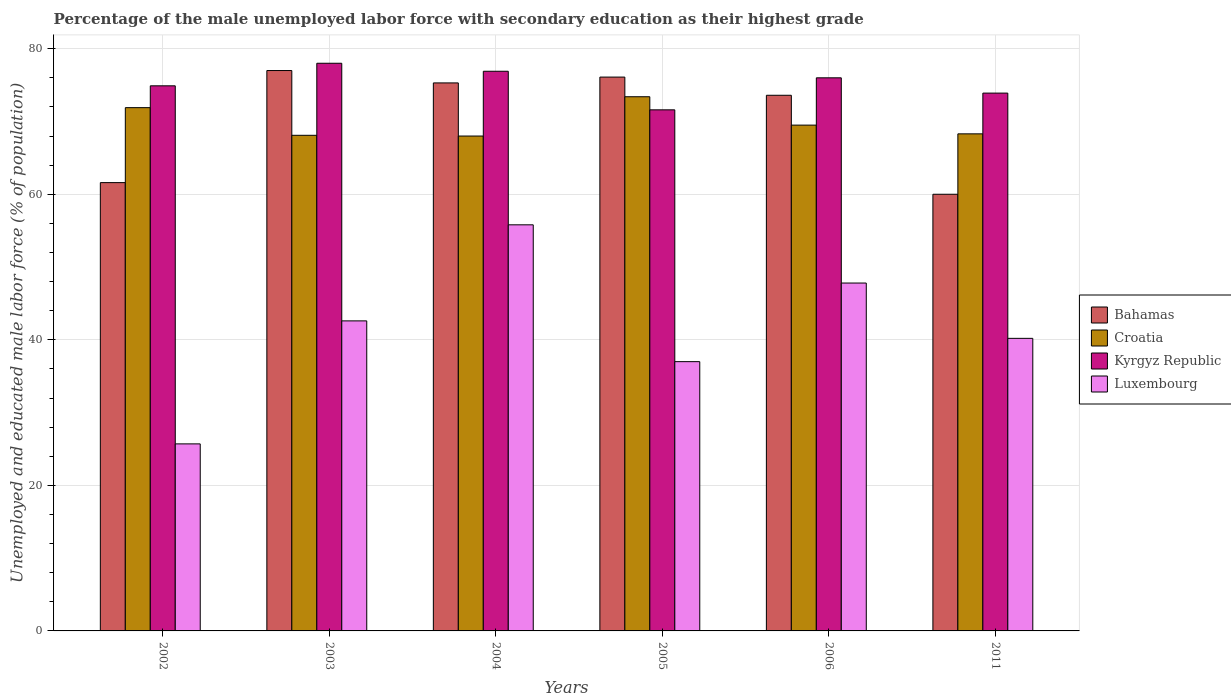How many different coloured bars are there?
Your answer should be compact. 4. How many groups of bars are there?
Offer a very short reply. 6. Are the number of bars per tick equal to the number of legend labels?
Provide a short and direct response. Yes. Are the number of bars on each tick of the X-axis equal?
Ensure brevity in your answer.  Yes. What is the percentage of the unemployed male labor force with secondary education in Luxembourg in 2011?
Your response must be concise. 40.2. Across all years, what is the maximum percentage of the unemployed male labor force with secondary education in Croatia?
Offer a terse response. 73.4. Across all years, what is the minimum percentage of the unemployed male labor force with secondary education in Kyrgyz Republic?
Offer a terse response. 71.6. In which year was the percentage of the unemployed male labor force with secondary education in Croatia maximum?
Your answer should be very brief. 2005. What is the total percentage of the unemployed male labor force with secondary education in Bahamas in the graph?
Offer a terse response. 423.6. What is the difference between the percentage of the unemployed male labor force with secondary education in Luxembourg in 2005 and that in 2006?
Provide a short and direct response. -10.8. What is the difference between the percentage of the unemployed male labor force with secondary education in Luxembourg in 2003 and the percentage of the unemployed male labor force with secondary education in Bahamas in 2006?
Make the answer very short. -31. What is the average percentage of the unemployed male labor force with secondary education in Croatia per year?
Ensure brevity in your answer.  69.87. In the year 2011, what is the difference between the percentage of the unemployed male labor force with secondary education in Luxembourg and percentage of the unemployed male labor force with secondary education in Kyrgyz Republic?
Offer a terse response. -33.7. In how many years, is the percentage of the unemployed male labor force with secondary education in Kyrgyz Republic greater than 44 %?
Offer a very short reply. 6. What is the ratio of the percentage of the unemployed male labor force with secondary education in Bahamas in 2002 to that in 2011?
Offer a very short reply. 1.03. Is the difference between the percentage of the unemployed male labor force with secondary education in Luxembourg in 2002 and 2004 greater than the difference between the percentage of the unemployed male labor force with secondary education in Kyrgyz Republic in 2002 and 2004?
Provide a succinct answer. No. What is the difference between the highest and the second highest percentage of the unemployed male labor force with secondary education in Luxembourg?
Provide a succinct answer. 8. What is the difference between the highest and the lowest percentage of the unemployed male labor force with secondary education in Croatia?
Your answer should be very brief. 5.4. Is the sum of the percentage of the unemployed male labor force with secondary education in Bahamas in 2002 and 2004 greater than the maximum percentage of the unemployed male labor force with secondary education in Luxembourg across all years?
Give a very brief answer. Yes. Is it the case that in every year, the sum of the percentage of the unemployed male labor force with secondary education in Kyrgyz Republic and percentage of the unemployed male labor force with secondary education in Luxembourg is greater than the sum of percentage of the unemployed male labor force with secondary education in Bahamas and percentage of the unemployed male labor force with secondary education in Croatia?
Provide a succinct answer. No. What does the 3rd bar from the left in 2006 represents?
Provide a succinct answer. Kyrgyz Republic. What does the 1st bar from the right in 2006 represents?
Offer a terse response. Luxembourg. How many bars are there?
Provide a succinct answer. 24. How many years are there in the graph?
Provide a succinct answer. 6. What is the difference between two consecutive major ticks on the Y-axis?
Offer a terse response. 20. Where does the legend appear in the graph?
Offer a terse response. Center right. How many legend labels are there?
Offer a terse response. 4. What is the title of the graph?
Your answer should be compact. Percentage of the male unemployed labor force with secondary education as their highest grade. Does "Iraq" appear as one of the legend labels in the graph?
Make the answer very short. No. What is the label or title of the X-axis?
Give a very brief answer. Years. What is the label or title of the Y-axis?
Your answer should be very brief. Unemployed and educated male labor force (% of population). What is the Unemployed and educated male labor force (% of population) in Bahamas in 2002?
Provide a succinct answer. 61.6. What is the Unemployed and educated male labor force (% of population) of Croatia in 2002?
Keep it short and to the point. 71.9. What is the Unemployed and educated male labor force (% of population) of Kyrgyz Republic in 2002?
Your response must be concise. 74.9. What is the Unemployed and educated male labor force (% of population) of Luxembourg in 2002?
Your answer should be compact. 25.7. What is the Unemployed and educated male labor force (% of population) of Bahamas in 2003?
Make the answer very short. 77. What is the Unemployed and educated male labor force (% of population) in Croatia in 2003?
Offer a very short reply. 68.1. What is the Unemployed and educated male labor force (% of population) of Kyrgyz Republic in 2003?
Offer a very short reply. 78. What is the Unemployed and educated male labor force (% of population) of Luxembourg in 2003?
Make the answer very short. 42.6. What is the Unemployed and educated male labor force (% of population) of Bahamas in 2004?
Your response must be concise. 75.3. What is the Unemployed and educated male labor force (% of population) of Croatia in 2004?
Keep it short and to the point. 68. What is the Unemployed and educated male labor force (% of population) of Kyrgyz Republic in 2004?
Offer a terse response. 76.9. What is the Unemployed and educated male labor force (% of population) in Luxembourg in 2004?
Ensure brevity in your answer.  55.8. What is the Unemployed and educated male labor force (% of population) in Bahamas in 2005?
Keep it short and to the point. 76.1. What is the Unemployed and educated male labor force (% of population) in Croatia in 2005?
Your answer should be very brief. 73.4. What is the Unemployed and educated male labor force (% of population) of Kyrgyz Republic in 2005?
Make the answer very short. 71.6. What is the Unemployed and educated male labor force (% of population) of Luxembourg in 2005?
Offer a terse response. 37. What is the Unemployed and educated male labor force (% of population) of Bahamas in 2006?
Offer a terse response. 73.6. What is the Unemployed and educated male labor force (% of population) in Croatia in 2006?
Give a very brief answer. 69.5. What is the Unemployed and educated male labor force (% of population) in Kyrgyz Republic in 2006?
Offer a terse response. 76. What is the Unemployed and educated male labor force (% of population) of Luxembourg in 2006?
Offer a very short reply. 47.8. What is the Unemployed and educated male labor force (% of population) in Bahamas in 2011?
Provide a short and direct response. 60. What is the Unemployed and educated male labor force (% of population) in Croatia in 2011?
Keep it short and to the point. 68.3. What is the Unemployed and educated male labor force (% of population) of Kyrgyz Republic in 2011?
Ensure brevity in your answer.  73.9. What is the Unemployed and educated male labor force (% of population) in Luxembourg in 2011?
Provide a short and direct response. 40.2. Across all years, what is the maximum Unemployed and educated male labor force (% of population) of Croatia?
Keep it short and to the point. 73.4. Across all years, what is the maximum Unemployed and educated male labor force (% of population) of Luxembourg?
Give a very brief answer. 55.8. Across all years, what is the minimum Unemployed and educated male labor force (% of population) in Bahamas?
Give a very brief answer. 60. Across all years, what is the minimum Unemployed and educated male labor force (% of population) in Croatia?
Make the answer very short. 68. Across all years, what is the minimum Unemployed and educated male labor force (% of population) in Kyrgyz Republic?
Provide a short and direct response. 71.6. Across all years, what is the minimum Unemployed and educated male labor force (% of population) of Luxembourg?
Your answer should be compact. 25.7. What is the total Unemployed and educated male labor force (% of population) of Bahamas in the graph?
Your answer should be compact. 423.6. What is the total Unemployed and educated male labor force (% of population) of Croatia in the graph?
Offer a very short reply. 419.2. What is the total Unemployed and educated male labor force (% of population) in Kyrgyz Republic in the graph?
Your response must be concise. 451.3. What is the total Unemployed and educated male labor force (% of population) of Luxembourg in the graph?
Your response must be concise. 249.1. What is the difference between the Unemployed and educated male labor force (% of population) of Bahamas in 2002 and that in 2003?
Keep it short and to the point. -15.4. What is the difference between the Unemployed and educated male labor force (% of population) of Luxembourg in 2002 and that in 2003?
Your answer should be very brief. -16.9. What is the difference between the Unemployed and educated male labor force (% of population) of Bahamas in 2002 and that in 2004?
Offer a very short reply. -13.7. What is the difference between the Unemployed and educated male labor force (% of population) of Kyrgyz Republic in 2002 and that in 2004?
Provide a short and direct response. -2. What is the difference between the Unemployed and educated male labor force (% of population) in Luxembourg in 2002 and that in 2004?
Give a very brief answer. -30.1. What is the difference between the Unemployed and educated male labor force (% of population) in Kyrgyz Republic in 2002 and that in 2005?
Provide a succinct answer. 3.3. What is the difference between the Unemployed and educated male labor force (% of population) of Luxembourg in 2002 and that in 2005?
Provide a succinct answer. -11.3. What is the difference between the Unemployed and educated male labor force (% of population) of Bahamas in 2002 and that in 2006?
Ensure brevity in your answer.  -12. What is the difference between the Unemployed and educated male labor force (% of population) of Kyrgyz Republic in 2002 and that in 2006?
Provide a short and direct response. -1.1. What is the difference between the Unemployed and educated male labor force (% of population) in Luxembourg in 2002 and that in 2006?
Give a very brief answer. -22.1. What is the difference between the Unemployed and educated male labor force (% of population) of Bahamas in 2003 and that in 2004?
Give a very brief answer. 1.7. What is the difference between the Unemployed and educated male labor force (% of population) of Croatia in 2003 and that in 2004?
Provide a short and direct response. 0.1. What is the difference between the Unemployed and educated male labor force (% of population) of Bahamas in 2003 and that in 2005?
Offer a very short reply. 0.9. What is the difference between the Unemployed and educated male labor force (% of population) of Croatia in 2003 and that in 2005?
Offer a very short reply. -5.3. What is the difference between the Unemployed and educated male labor force (% of population) of Croatia in 2003 and that in 2011?
Keep it short and to the point. -0.2. What is the difference between the Unemployed and educated male labor force (% of population) in Kyrgyz Republic in 2003 and that in 2011?
Give a very brief answer. 4.1. What is the difference between the Unemployed and educated male labor force (% of population) in Luxembourg in 2003 and that in 2011?
Provide a succinct answer. 2.4. What is the difference between the Unemployed and educated male labor force (% of population) of Bahamas in 2004 and that in 2005?
Make the answer very short. -0.8. What is the difference between the Unemployed and educated male labor force (% of population) in Kyrgyz Republic in 2004 and that in 2005?
Make the answer very short. 5.3. What is the difference between the Unemployed and educated male labor force (% of population) in Croatia in 2004 and that in 2006?
Make the answer very short. -1.5. What is the difference between the Unemployed and educated male labor force (% of population) of Kyrgyz Republic in 2004 and that in 2006?
Offer a very short reply. 0.9. What is the difference between the Unemployed and educated male labor force (% of population) of Luxembourg in 2004 and that in 2006?
Offer a very short reply. 8. What is the difference between the Unemployed and educated male labor force (% of population) of Bahamas in 2004 and that in 2011?
Make the answer very short. 15.3. What is the difference between the Unemployed and educated male labor force (% of population) of Croatia in 2004 and that in 2011?
Your response must be concise. -0.3. What is the difference between the Unemployed and educated male labor force (% of population) of Bahamas in 2005 and that in 2006?
Ensure brevity in your answer.  2.5. What is the difference between the Unemployed and educated male labor force (% of population) of Luxembourg in 2005 and that in 2006?
Give a very brief answer. -10.8. What is the difference between the Unemployed and educated male labor force (% of population) in Croatia in 2005 and that in 2011?
Your response must be concise. 5.1. What is the difference between the Unemployed and educated male labor force (% of population) of Croatia in 2006 and that in 2011?
Give a very brief answer. 1.2. What is the difference between the Unemployed and educated male labor force (% of population) in Luxembourg in 2006 and that in 2011?
Your response must be concise. 7.6. What is the difference between the Unemployed and educated male labor force (% of population) of Bahamas in 2002 and the Unemployed and educated male labor force (% of population) of Kyrgyz Republic in 2003?
Your answer should be very brief. -16.4. What is the difference between the Unemployed and educated male labor force (% of population) in Bahamas in 2002 and the Unemployed and educated male labor force (% of population) in Luxembourg in 2003?
Offer a terse response. 19. What is the difference between the Unemployed and educated male labor force (% of population) in Croatia in 2002 and the Unemployed and educated male labor force (% of population) in Kyrgyz Republic in 2003?
Provide a short and direct response. -6.1. What is the difference between the Unemployed and educated male labor force (% of population) in Croatia in 2002 and the Unemployed and educated male labor force (% of population) in Luxembourg in 2003?
Make the answer very short. 29.3. What is the difference between the Unemployed and educated male labor force (% of population) of Kyrgyz Republic in 2002 and the Unemployed and educated male labor force (% of population) of Luxembourg in 2003?
Provide a succinct answer. 32.3. What is the difference between the Unemployed and educated male labor force (% of population) of Bahamas in 2002 and the Unemployed and educated male labor force (% of population) of Croatia in 2004?
Provide a short and direct response. -6.4. What is the difference between the Unemployed and educated male labor force (% of population) of Bahamas in 2002 and the Unemployed and educated male labor force (% of population) of Kyrgyz Republic in 2004?
Keep it short and to the point. -15.3. What is the difference between the Unemployed and educated male labor force (% of population) in Bahamas in 2002 and the Unemployed and educated male labor force (% of population) in Luxembourg in 2004?
Offer a terse response. 5.8. What is the difference between the Unemployed and educated male labor force (% of population) of Croatia in 2002 and the Unemployed and educated male labor force (% of population) of Kyrgyz Republic in 2004?
Your response must be concise. -5. What is the difference between the Unemployed and educated male labor force (% of population) of Kyrgyz Republic in 2002 and the Unemployed and educated male labor force (% of population) of Luxembourg in 2004?
Offer a terse response. 19.1. What is the difference between the Unemployed and educated male labor force (% of population) in Bahamas in 2002 and the Unemployed and educated male labor force (% of population) in Luxembourg in 2005?
Provide a succinct answer. 24.6. What is the difference between the Unemployed and educated male labor force (% of population) in Croatia in 2002 and the Unemployed and educated male labor force (% of population) in Kyrgyz Republic in 2005?
Your answer should be compact. 0.3. What is the difference between the Unemployed and educated male labor force (% of population) in Croatia in 2002 and the Unemployed and educated male labor force (% of population) in Luxembourg in 2005?
Your answer should be compact. 34.9. What is the difference between the Unemployed and educated male labor force (% of population) in Kyrgyz Republic in 2002 and the Unemployed and educated male labor force (% of population) in Luxembourg in 2005?
Your response must be concise. 37.9. What is the difference between the Unemployed and educated male labor force (% of population) in Bahamas in 2002 and the Unemployed and educated male labor force (% of population) in Kyrgyz Republic in 2006?
Make the answer very short. -14.4. What is the difference between the Unemployed and educated male labor force (% of population) in Bahamas in 2002 and the Unemployed and educated male labor force (% of population) in Luxembourg in 2006?
Provide a succinct answer. 13.8. What is the difference between the Unemployed and educated male labor force (% of population) in Croatia in 2002 and the Unemployed and educated male labor force (% of population) in Luxembourg in 2006?
Your answer should be very brief. 24.1. What is the difference between the Unemployed and educated male labor force (% of population) in Kyrgyz Republic in 2002 and the Unemployed and educated male labor force (% of population) in Luxembourg in 2006?
Give a very brief answer. 27.1. What is the difference between the Unemployed and educated male labor force (% of population) of Bahamas in 2002 and the Unemployed and educated male labor force (% of population) of Kyrgyz Republic in 2011?
Make the answer very short. -12.3. What is the difference between the Unemployed and educated male labor force (% of population) of Bahamas in 2002 and the Unemployed and educated male labor force (% of population) of Luxembourg in 2011?
Keep it short and to the point. 21.4. What is the difference between the Unemployed and educated male labor force (% of population) of Croatia in 2002 and the Unemployed and educated male labor force (% of population) of Luxembourg in 2011?
Your answer should be compact. 31.7. What is the difference between the Unemployed and educated male labor force (% of population) in Kyrgyz Republic in 2002 and the Unemployed and educated male labor force (% of population) in Luxembourg in 2011?
Provide a succinct answer. 34.7. What is the difference between the Unemployed and educated male labor force (% of population) of Bahamas in 2003 and the Unemployed and educated male labor force (% of population) of Kyrgyz Republic in 2004?
Make the answer very short. 0.1. What is the difference between the Unemployed and educated male labor force (% of population) in Bahamas in 2003 and the Unemployed and educated male labor force (% of population) in Luxembourg in 2004?
Offer a terse response. 21.2. What is the difference between the Unemployed and educated male labor force (% of population) of Kyrgyz Republic in 2003 and the Unemployed and educated male labor force (% of population) of Luxembourg in 2004?
Offer a very short reply. 22.2. What is the difference between the Unemployed and educated male labor force (% of population) of Bahamas in 2003 and the Unemployed and educated male labor force (% of population) of Croatia in 2005?
Give a very brief answer. 3.6. What is the difference between the Unemployed and educated male labor force (% of population) of Croatia in 2003 and the Unemployed and educated male labor force (% of population) of Kyrgyz Republic in 2005?
Keep it short and to the point. -3.5. What is the difference between the Unemployed and educated male labor force (% of population) of Croatia in 2003 and the Unemployed and educated male labor force (% of population) of Luxembourg in 2005?
Your response must be concise. 31.1. What is the difference between the Unemployed and educated male labor force (% of population) of Kyrgyz Republic in 2003 and the Unemployed and educated male labor force (% of population) of Luxembourg in 2005?
Provide a succinct answer. 41. What is the difference between the Unemployed and educated male labor force (% of population) in Bahamas in 2003 and the Unemployed and educated male labor force (% of population) in Kyrgyz Republic in 2006?
Ensure brevity in your answer.  1. What is the difference between the Unemployed and educated male labor force (% of population) in Bahamas in 2003 and the Unemployed and educated male labor force (% of population) in Luxembourg in 2006?
Make the answer very short. 29.2. What is the difference between the Unemployed and educated male labor force (% of population) of Croatia in 2003 and the Unemployed and educated male labor force (% of population) of Kyrgyz Republic in 2006?
Keep it short and to the point. -7.9. What is the difference between the Unemployed and educated male labor force (% of population) in Croatia in 2003 and the Unemployed and educated male labor force (% of population) in Luxembourg in 2006?
Make the answer very short. 20.3. What is the difference between the Unemployed and educated male labor force (% of population) of Kyrgyz Republic in 2003 and the Unemployed and educated male labor force (% of population) of Luxembourg in 2006?
Provide a short and direct response. 30.2. What is the difference between the Unemployed and educated male labor force (% of population) in Bahamas in 2003 and the Unemployed and educated male labor force (% of population) in Luxembourg in 2011?
Your answer should be compact. 36.8. What is the difference between the Unemployed and educated male labor force (% of population) of Croatia in 2003 and the Unemployed and educated male labor force (% of population) of Kyrgyz Republic in 2011?
Give a very brief answer. -5.8. What is the difference between the Unemployed and educated male labor force (% of population) of Croatia in 2003 and the Unemployed and educated male labor force (% of population) of Luxembourg in 2011?
Your answer should be very brief. 27.9. What is the difference between the Unemployed and educated male labor force (% of population) of Kyrgyz Republic in 2003 and the Unemployed and educated male labor force (% of population) of Luxembourg in 2011?
Your answer should be very brief. 37.8. What is the difference between the Unemployed and educated male labor force (% of population) of Bahamas in 2004 and the Unemployed and educated male labor force (% of population) of Croatia in 2005?
Ensure brevity in your answer.  1.9. What is the difference between the Unemployed and educated male labor force (% of population) of Bahamas in 2004 and the Unemployed and educated male labor force (% of population) of Kyrgyz Republic in 2005?
Your answer should be very brief. 3.7. What is the difference between the Unemployed and educated male labor force (% of population) in Bahamas in 2004 and the Unemployed and educated male labor force (% of population) in Luxembourg in 2005?
Provide a succinct answer. 38.3. What is the difference between the Unemployed and educated male labor force (% of population) in Croatia in 2004 and the Unemployed and educated male labor force (% of population) in Luxembourg in 2005?
Keep it short and to the point. 31. What is the difference between the Unemployed and educated male labor force (% of population) in Kyrgyz Republic in 2004 and the Unemployed and educated male labor force (% of population) in Luxembourg in 2005?
Ensure brevity in your answer.  39.9. What is the difference between the Unemployed and educated male labor force (% of population) in Bahamas in 2004 and the Unemployed and educated male labor force (% of population) in Croatia in 2006?
Your answer should be very brief. 5.8. What is the difference between the Unemployed and educated male labor force (% of population) of Bahamas in 2004 and the Unemployed and educated male labor force (% of population) of Kyrgyz Republic in 2006?
Keep it short and to the point. -0.7. What is the difference between the Unemployed and educated male labor force (% of population) of Bahamas in 2004 and the Unemployed and educated male labor force (% of population) of Luxembourg in 2006?
Provide a short and direct response. 27.5. What is the difference between the Unemployed and educated male labor force (% of population) of Croatia in 2004 and the Unemployed and educated male labor force (% of population) of Kyrgyz Republic in 2006?
Provide a short and direct response. -8. What is the difference between the Unemployed and educated male labor force (% of population) of Croatia in 2004 and the Unemployed and educated male labor force (% of population) of Luxembourg in 2006?
Give a very brief answer. 20.2. What is the difference between the Unemployed and educated male labor force (% of population) of Kyrgyz Republic in 2004 and the Unemployed and educated male labor force (% of population) of Luxembourg in 2006?
Your answer should be very brief. 29.1. What is the difference between the Unemployed and educated male labor force (% of population) of Bahamas in 2004 and the Unemployed and educated male labor force (% of population) of Kyrgyz Republic in 2011?
Provide a succinct answer. 1.4. What is the difference between the Unemployed and educated male labor force (% of population) in Bahamas in 2004 and the Unemployed and educated male labor force (% of population) in Luxembourg in 2011?
Ensure brevity in your answer.  35.1. What is the difference between the Unemployed and educated male labor force (% of population) of Croatia in 2004 and the Unemployed and educated male labor force (% of population) of Kyrgyz Republic in 2011?
Provide a succinct answer. -5.9. What is the difference between the Unemployed and educated male labor force (% of population) in Croatia in 2004 and the Unemployed and educated male labor force (% of population) in Luxembourg in 2011?
Ensure brevity in your answer.  27.8. What is the difference between the Unemployed and educated male labor force (% of population) in Kyrgyz Republic in 2004 and the Unemployed and educated male labor force (% of population) in Luxembourg in 2011?
Your answer should be compact. 36.7. What is the difference between the Unemployed and educated male labor force (% of population) of Bahamas in 2005 and the Unemployed and educated male labor force (% of population) of Kyrgyz Republic in 2006?
Make the answer very short. 0.1. What is the difference between the Unemployed and educated male labor force (% of population) of Bahamas in 2005 and the Unemployed and educated male labor force (% of population) of Luxembourg in 2006?
Give a very brief answer. 28.3. What is the difference between the Unemployed and educated male labor force (% of population) of Croatia in 2005 and the Unemployed and educated male labor force (% of population) of Luxembourg in 2006?
Provide a short and direct response. 25.6. What is the difference between the Unemployed and educated male labor force (% of population) of Kyrgyz Republic in 2005 and the Unemployed and educated male labor force (% of population) of Luxembourg in 2006?
Make the answer very short. 23.8. What is the difference between the Unemployed and educated male labor force (% of population) of Bahamas in 2005 and the Unemployed and educated male labor force (% of population) of Kyrgyz Republic in 2011?
Provide a short and direct response. 2.2. What is the difference between the Unemployed and educated male labor force (% of population) in Bahamas in 2005 and the Unemployed and educated male labor force (% of population) in Luxembourg in 2011?
Ensure brevity in your answer.  35.9. What is the difference between the Unemployed and educated male labor force (% of population) in Croatia in 2005 and the Unemployed and educated male labor force (% of population) in Luxembourg in 2011?
Provide a succinct answer. 33.2. What is the difference between the Unemployed and educated male labor force (% of population) of Kyrgyz Republic in 2005 and the Unemployed and educated male labor force (% of population) of Luxembourg in 2011?
Your answer should be very brief. 31.4. What is the difference between the Unemployed and educated male labor force (% of population) in Bahamas in 2006 and the Unemployed and educated male labor force (% of population) in Croatia in 2011?
Offer a terse response. 5.3. What is the difference between the Unemployed and educated male labor force (% of population) of Bahamas in 2006 and the Unemployed and educated male labor force (% of population) of Luxembourg in 2011?
Give a very brief answer. 33.4. What is the difference between the Unemployed and educated male labor force (% of population) in Croatia in 2006 and the Unemployed and educated male labor force (% of population) in Luxembourg in 2011?
Offer a terse response. 29.3. What is the difference between the Unemployed and educated male labor force (% of population) of Kyrgyz Republic in 2006 and the Unemployed and educated male labor force (% of population) of Luxembourg in 2011?
Provide a short and direct response. 35.8. What is the average Unemployed and educated male labor force (% of population) of Bahamas per year?
Provide a succinct answer. 70.6. What is the average Unemployed and educated male labor force (% of population) in Croatia per year?
Provide a short and direct response. 69.87. What is the average Unemployed and educated male labor force (% of population) in Kyrgyz Republic per year?
Provide a short and direct response. 75.22. What is the average Unemployed and educated male labor force (% of population) in Luxembourg per year?
Provide a succinct answer. 41.52. In the year 2002, what is the difference between the Unemployed and educated male labor force (% of population) of Bahamas and Unemployed and educated male labor force (% of population) of Luxembourg?
Your answer should be very brief. 35.9. In the year 2002, what is the difference between the Unemployed and educated male labor force (% of population) of Croatia and Unemployed and educated male labor force (% of population) of Luxembourg?
Provide a short and direct response. 46.2. In the year 2002, what is the difference between the Unemployed and educated male labor force (% of population) in Kyrgyz Republic and Unemployed and educated male labor force (% of population) in Luxembourg?
Provide a short and direct response. 49.2. In the year 2003, what is the difference between the Unemployed and educated male labor force (% of population) in Bahamas and Unemployed and educated male labor force (% of population) in Croatia?
Ensure brevity in your answer.  8.9. In the year 2003, what is the difference between the Unemployed and educated male labor force (% of population) in Bahamas and Unemployed and educated male labor force (% of population) in Luxembourg?
Ensure brevity in your answer.  34.4. In the year 2003, what is the difference between the Unemployed and educated male labor force (% of population) of Kyrgyz Republic and Unemployed and educated male labor force (% of population) of Luxembourg?
Give a very brief answer. 35.4. In the year 2004, what is the difference between the Unemployed and educated male labor force (% of population) in Bahamas and Unemployed and educated male labor force (% of population) in Luxembourg?
Make the answer very short. 19.5. In the year 2004, what is the difference between the Unemployed and educated male labor force (% of population) in Kyrgyz Republic and Unemployed and educated male labor force (% of population) in Luxembourg?
Your answer should be very brief. 21.1. In the year 2005, what is the difference between the Unemployed and educated male labor force (% of population) of Bahamas and Unemployed and educated male labor force (% of population) of Kyrgyz Republic?
Offer a very short reply. 4.5. In the year 2005, what is the difference between the Unemployed and educated male labor force (% of population) in Bahamas and Unemployed and educated male labor force (% of population) in Luxembourg?
Give a very brief answer. 39.1. In the year 2005, what is the difference between the Unemployed and educated male labor force (% of population) in Croatia and Unemployed and educated male labor force (% of population) in Luxembourg?
Provide a succinct answer. 36.4. In the year 2005, what is the difference between the Unemployed and educated male labor force (% of population) of Kyrgyz Republic and Unemployed and educated male labor force (% of population) of Luxembourg?
Your response must be concise. 34.6. In the year 2006, what is the difference between the Unemployed and educated male labor force (% of population) in Bahamas and Unemployed and educated male labor force (% of population) in Luxembourg?
Your answer should be compact. 25.8. In the year 2006, what is the difference between the Unemployed and educated male labor force (% of population) of Croatia and Unemployed and educated male labor force (% of population) of Luxembourg?
Provide a short and direct response. 21.7. In the year 2006, what is the difference between the Unemployed and educated male labor force (% of population) in Kyrgyz Republic and Unemployed and educated male labor force (% of population) in Luxembourg?
Your response must be concise. 28.2. In the year 2011, what is the difference between the Unemployed and educated male labor force (% of population) of Bahamas and Unemployed and educated male labor force (% of population) of Croatia?
Keep it short and to the point. -8.3. In the year 2011, what is the difference between the Unemployed and educated male labor force (% of population) of Bahamas and Unemployed and educated male labor force (% of population) of Kyrgyz Republic?
Offer a very short reply. -13.9. In the year 2011, what is the difference between the Unemployed and educated male labor force (% of population) of Bahamas and Unemployed and educated male labor force (% of population) of Luxembourg?
Your answer should be very brief. 19.8. In the year 2011, what is the difference between the Unemployed and educated male labor force (% of population) of Croatia and Unemployed and educated male labor force (% of population) of Kyrgyz Republic?
Your answer should be very brief. -5.6. In the year 2011, what is the difference between the Unemployed and educated male labor force (% of population) of Croatia and Unemployed and educated male labor force (% of population) of Luxembourg?
Your answer should be compact. 28.1. In the year 2011, what is the difference between the Unemployed and educated male labor force (% of population) in Kyrgyz Republic and Unemployed and educated male labor force (% of population) in Luxembourg?
Offer a terse response. 33.7. What is the ratio of the Unemployed and educated male labor force (% of population) of Croatia in 2002 to that in 2003?
Your answer should be compact. 1.06. What is the ratio of the Unemployed and educated male labor force (% of population) of Kyrgyz Republic in 2002 to that in 2003?
Provide a short and direct response. 0.96. What is the ratio of the Unemployed and educated male labor force (% of population) in Luxembourg in 2002 to that in 2003?
Ensure brevity in your answer.  0.6. What is the ratio of the Unemployed and educated male labor force (% of population) of Bahamas in 2002 to that in 2004?
Make the answer very short. 0.82. What is the ratio of the Unemployed and educated male labor force (% of population) of Croatia in 2002 to that in 2004?
Provide a succinct answer. 1.06. What is the ratio of the Unemployed and educated male labor force (% of population) in Kyrgyz Republic in 2002 to that in 2004?
Give a very brief answer. 0.97. What is the ratio of the Unemployed and educated male labor force (% of population) of Luxembourg in 2002 to that in 2004?
Keep it short and to the point. 0.46. What is the ratio of the Unemployed and educated male labor force (% of population) of Bahamas in 2002 to that in 2005?
Ensure brevity in your answer.  0.81. What is the ratio of the Unemployed and educated male labor force (% of population) of Croatia in 2002 to that in 2005?
Keep it short and to the point. 0.98. What is the ratio of the Unemployed and educated male labor force (% of population) in Kyrgyz Republic in 2002 to that in 2005?
Ensure brevity in your answer.  1.05. What is the ratio of the Unemployed and educated male labor force (% of population) in Luxembourg in 2002 to that in 2005?
Ensure brevity in your answer.  0.69. What is the ratio of the Unemployed and educated male labor force (% of population) in Bahamas in 2002 to that in 2006?
Your answer should be very brief. 0.84. What is the ratio of the Unemployed and educated male labor force (% of population) of Croatia in 2002 to that in 2006?
Ensure brevity in your answer.  1.03. What is the ratio of the Unemployed and educated male labor force (% of population) in Kyrgyz Republic in 2002 to that in 2006?
Ensure brevity in your answer.  0.99. What is the ratio of the Unemployed and educated male labor force (% of population) in Luxembourg in 2002 to that in 2006?
Provide a short and direct response. 0.54. What is the ratio of the Unemployed and educated male labor force (% of population) in Bahamas in 2002 to that in 2011?
Ensure brevity in your answer.  1.03. What is the ratio of the Unemployed and educated male labor force (% of population) of Croatia in 2002 to that in 2011?
Keep it short and to the point. 1.05. What is the ratio of the Unemployed and educated male labor force (% of population) in Kyrgyz Republic in 2002 to that in 2011?
Your response must be concise. 1.01. What is the ratio of the Unemployed and educated male labor force (% of population) in Luxembourg in 2002 to that in 2011?
Make the answer very short. 0.64. What is the ratio of the Unemployed and educated male labor force (% of population) in Bahamas in 2003 to that in 2004?
Keep it short and to the point. 1.02. What is the ratio of the Unemployed and educated male labor force (% of population) in Croatia in 2003 to that in 2004?
Make the answer very short. 1. What is the ratio of the Unemployed and educated male labor force (% of population) of Kyrgyz Republic in 2003 to that in 2004?
Your answer should be compact. 1.01. What is the ratio of the Unemployed and educated male labor force (% of population) of Luxembourg in 2003 to that in 2004?
Your answer should be compact. 0.76. What is the ratio of the Unemployed and educated male labor force (% of population) in Bahamas in 2003 to that in 2005?
Give a very brief answer. 1.01. What is the ratio of the Unemployed and educated male labor force (% of population) in Croatia in 2003 to that in 2005?
Give a very brief answer. 0.93. What is the ratio of the Unemployed and educated male labor force (% of population) in Kyrgyz Republic in 2003 to that in 2005?
Ensure brevity in your answer.  1.09. What is the ratio of the Unemployed and educated male labor force (% of population) in Luxembourg in 2003 to that in 2005?
Offer a very short reply. 1.15. What is the ratio of the Unemployed and educated male labor force (% of population) in Bahamas in 2003 to that in 2006?
Your response must be concise. 1.05. What is the ratio of the Unemployed and educated male labor force (% of population) in Croatia in 2003 to that in 2006?
Your answer should be compact. 0.98. What is the ratio of the Unemployed and educated male labor force (% of population) in Kyrgyz Republic in 2003 to that in 2006?
Give a very brief answer. 1.03. What is the ratio of the Unemployed and educated male labor force (% of population) of Luxembourg in 2003 to that in 2006?
Your answer should be very brief. 0.89. What is the ratio of the Unemployed and educated male labor force (% of population) in Bahamas in 2003 to that in 2011?
Provide a succinct answer. 1.28. What is the ratio of the Unemployed and educated male labor force (% of population) of Kyrgyz Republic in 2003 to that in 2011?
Ensure brevity in your answer.  1.06. What is the ratio of the Unemployed and educated male labor force (% of population) in Luxembourg in 2003 to that in 2011?
Your response must be concise. 1.06. What is the ratio of the Unemployed and educated male labor force (% of population) in Croatia in 2004 to that in 2005?
Offer a terse response. 0.93. What is the ratio of the Unemployed and educated male labor force (% of population) in Kyrgyz Republic in 2004 to that in 2005?
Ensure brevity in your answer.  1.07. What is the ratio of the Unemployed and educated male labor force (% of population) in Luxembourg in 2004 to that in 2005?
Provide a succinct answer. 1.51. What is the ratio of the Unemployed and educated male labor force (% of population) of Bahamas in 2004 to that in 2006?
Provide a succinct answer. 1.02. What is the ratio of the Unemployed and educated male labor force (% of population) in Croatia in 2004 to that in 2006?
Give a very brief answer. 0.98. What is the ratio of the Unemployed and educated male labor force (% of population) of Kyrgyz Republic in 2004 to that in 2006?
Provide a succinct answer. 1.01. What is the ratio of the Unemployed and educated male labor force (% of population) in Luxembourg in 2004 to that in 2006?
Provide a short and direct response. 1.17. What is the ratio of the Unemployed and educated male labor force (% of population) in Bahamas in 2004 to that in 2011?
Provide a short and direct response. 1.25. What is the ratio of the Unemployed and educated male labor force (% of population) in Croatia in 2004 to that in 2011?
Your answer should be compact. 1. What is the ratio of the Unemployed and educated male labor force (% of population) of Kyrgyz Republic in 2004 to that in 2011?
Keep it short and to the point. 1.04. What is the ratio of the Unemployed and educated male labor force (% of population) of Luxembourg in 2004 to that in 2011?
Provide a succinct answer. 1.39. What is the ratio of the Unemployed and educated male labor force (% of population) of Bahamas in 2005 to that in 2006?
Ensure brevity in your answer.  1.03. What is the ratio of the Unemployed and educated male labor force (% of population) of Croatia in 2005 to that in 2006?
Offer a terse response. 1.06. What is the ratio of the Unemployed and educated male labor force (% of population) of Kyrgyz Republic in 2005 to that in 2006?
Keep it short and to the point. 0.94. What is the ratio of the Unemployed and educated male labor force (% of population) of Luxembourg in 2005 to that in 2006?
Your answer should be very brief. 0.77. What is the ratio of the Unemployed and educated male labor force (% of population) of Bahamas in 2005 to that in 2011?
Ensure brevity in your answer.  1.27. What is the ratio of the Unemployed and educated male labor force (% of population) of Croatia in 2005 to that in 2011?
Keep it short and to the point. 1.07. What is the ratio of the Unemployed and educated male labor force (% of population) in Kyrgyz Republic in 2005 to that in 2011?
Keep it short and to the point. 0.97. What is the ratio of the Unemployed and educated male labor force (% of population) in Luxembourg in 2005 to that in 2011?
Offer a very short reply. 0.92. What is the ratio of the Unemployed and educated male labor force (% of population) in Bahamas in 2006 to that in 2011?
Provide a succinct answer. 1.23. What is the ratio of the Unemployed and educated male labor force (% of population) of Croatia in 2006 to that in 2011?
Ensure brevity in your answer.  1.02. What is the ratio of the Unemployed and educated male labor force (% of population) of Kyrgyz Republic in 2006 to that in 2011?
Keep it short and to the point. 1.03. What is the ratio of the Unemployed and educated male labor force (% of population) in Luxembourg in 2006 to that in 2011?
Offer a very short reply. 1.19. What is the difference between the highest and the second highest Unemployed and educated male labor force (% of population) in Bahamas?
Keep it short and to the point. 0.9. What is the difference between the highest and the second highest Unemployed and educated male labor force (% of population) of Croatia?
Give a very brief answer. 1.5. What is the difference between the highest and the lowest Unemployed and educated male labor force (% of population) of Bahamas?
Offer a terse response. 17. What is the difference between the highest and the lowest Unemployed and educated male labor force (% of population) in Luxembourg?
Make the answer very short. 30.1. 